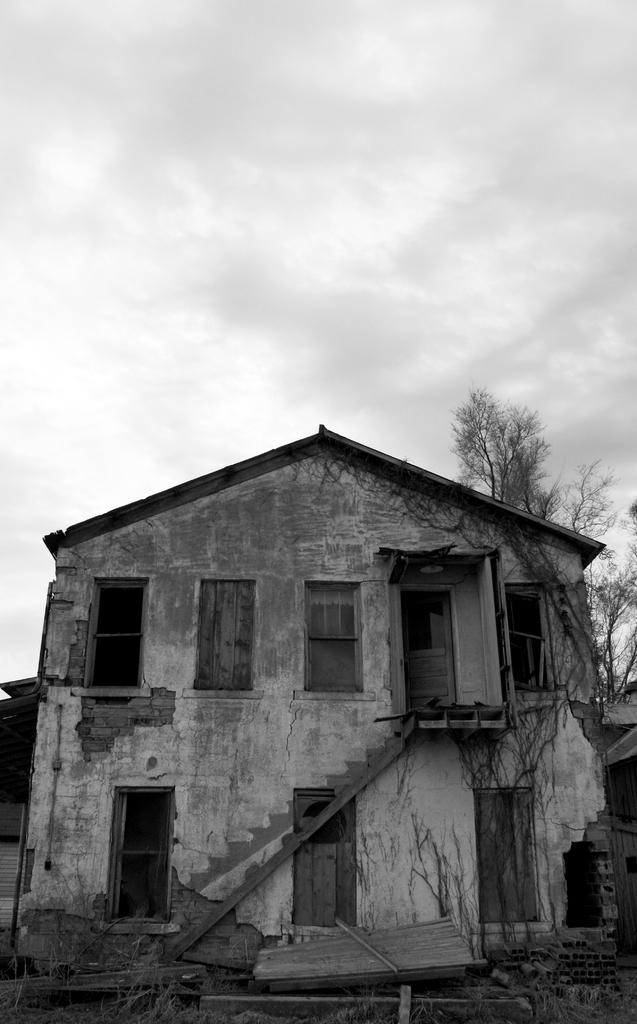What is the color scheme of the image? The image is black and white. What is the main subject of the image? There is a building in the image. What features can be observed on the building? The building has windows, doors, and steps. What other elements are present in the image? There are trees and the sky is visible in the background of the image. What is the condition of the sky in the image? The sky has clouds in it. Can you tell me how many umbrellas are open in the image? There are no umbrellas present in the image. What type of recess is visible in the building in the image? There is no recess visible in the building in the image. 